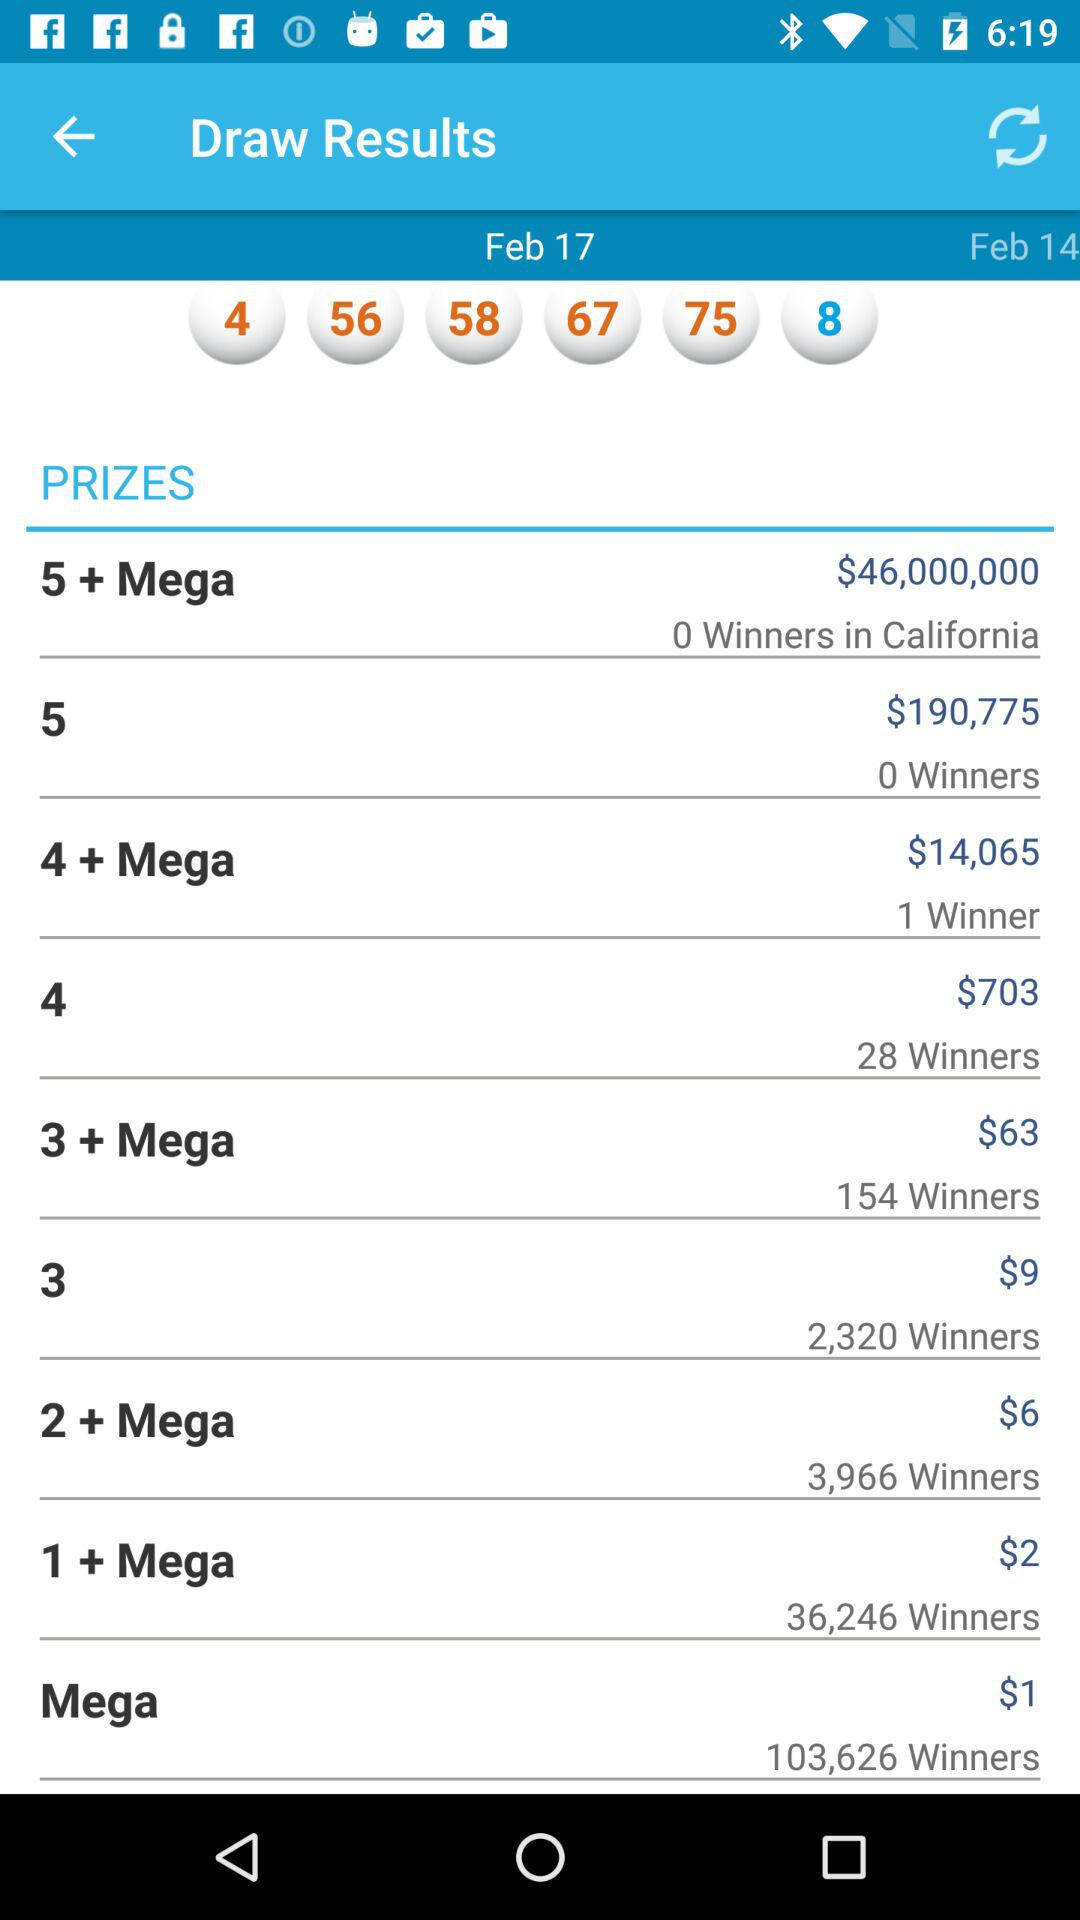Which prize was won by 154 winners? The prize that was won by 154 winners is "3 + Mega". 